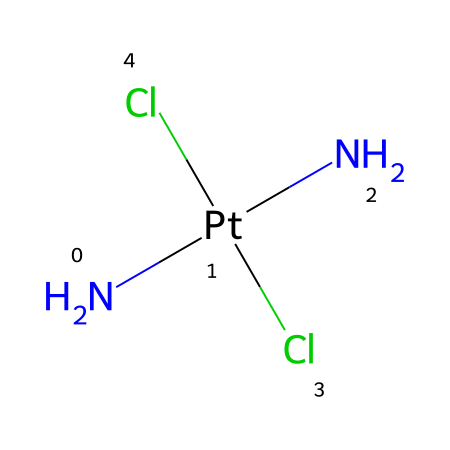What is the central metal atom in this compound? The compound shows platinum (Pt) as the central atom because it is located in the center of the coordination sphere and is bonded to ligands around it.
Answer: platinum How many amino groups are present in this compound? The SMILES representation indicates two nitrogen atoms that are part of amino groups attached to the platinum, denoting two amino groups in total.
Answer: 2 What type of ligands are present here? The structure features two chloride ions (Cl) and two amine groups (N), classifying them as ionic and neutral ligands respectively.
Answer: chloride and amine What is the coordination number of the platinum in this compound? The coordination number is determined by counting the number of ligands directly attached to the platinum atom; in this case, there are four ligands (two chloride ions and two amine groups), leading to a coordination number of 4.
Answer: 4 What is the geometry around the platinum atom in this compound? Given that there are four coordinating ligands around platinum, this arrangement typically leads to a square planar geometry, which is common for d8 metal complexes like platinum.
Answer: square planar What other applications does this compound have besides chemotherapy? While cisplatin is primarily known for its use in cancer treatment, it also has been researched for potential use in antimicrobial and antiviral therapies.
Answer: antimicrobial and antiviral What is the overall charge of this coordination complex? Since two chloride ions (which are -1 each) and two neutral amines are present, the overall charge is -2 derived from the two chloride ions' charges.
Answer: -2 